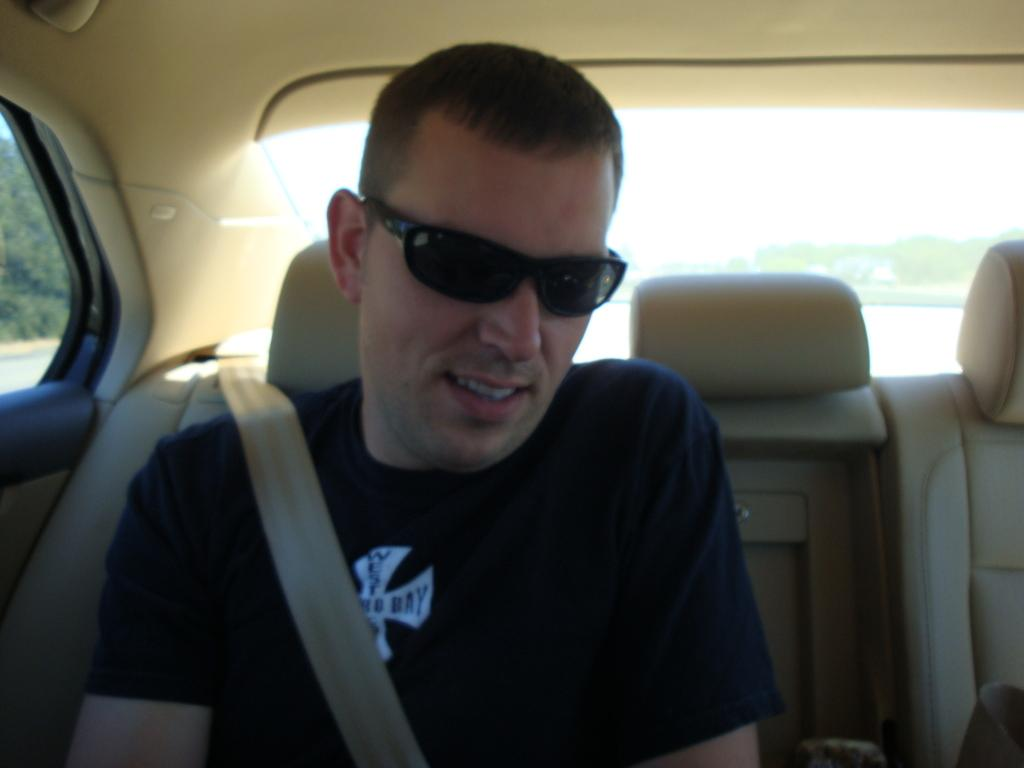Who is present in the image? There is a man in the image. What is the man doing in the image? The man is sitting on a car. What accessory is the man wearing in the image? The man is wearing spectacles. What can be seen on the left side of the image? There are trees on the left side of the image. What type of sign is the man holding in the image? There is no sign present in the image; the man is sitting on a car and wearing spectacles. 